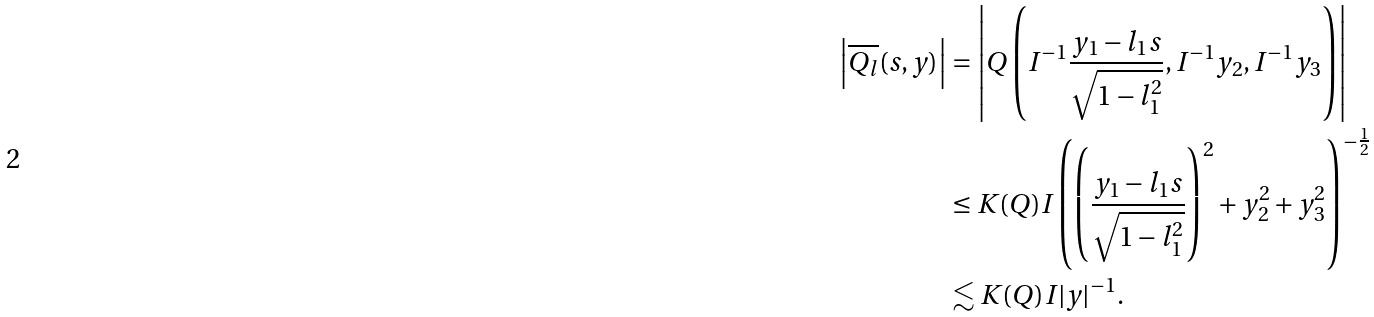<formula> <loc_0><loc_0><loc_500><loc_500>\left | \overline { Q _ { l } } ( s , y ) \right | & = \left | Q \left ( I ^ { - 1 } \frac { y _ { 1 } - l _ { 1 } s } { \sqrt { 1 - l _ { 1 } ^ { 2 } } } , I ^ { - 1 } y _ { 2 } , I ^ { - 1 } y _ { 3 } \right ) \right | \\ & \leq K ( Q ) I \left ( \left ( \frac { y _ { 1 } - l _ { 1 } s } { \sqrt { 1 - l _ { 1 } ^ { 2 } } } \right ) ^ { 2 } + y _ { 2 } ^ { 2 } + y _ { 3 } ^ { 2 } \right ) ^ { - \frac { 1 } { 2 } } \\ & \lesssim K ( Q ) I | y | ^ { - 1 } .</formula> 